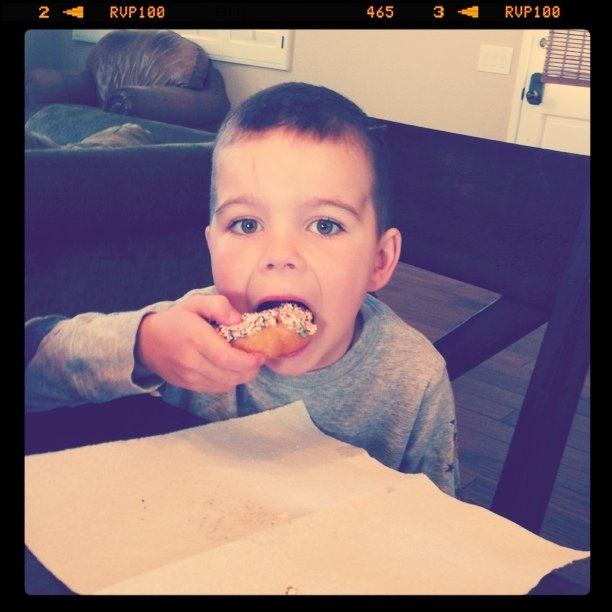Describe the objects in this image and their specific colors. I can see people in black, salmon, gray, purple, and tan tones, dining table in black, tan, and navy tones, chair in black, navy, and purple tones, couch in black, navy, blue, and gray tones, and chair in black, gray, navy, and darkblue tones in this image. 